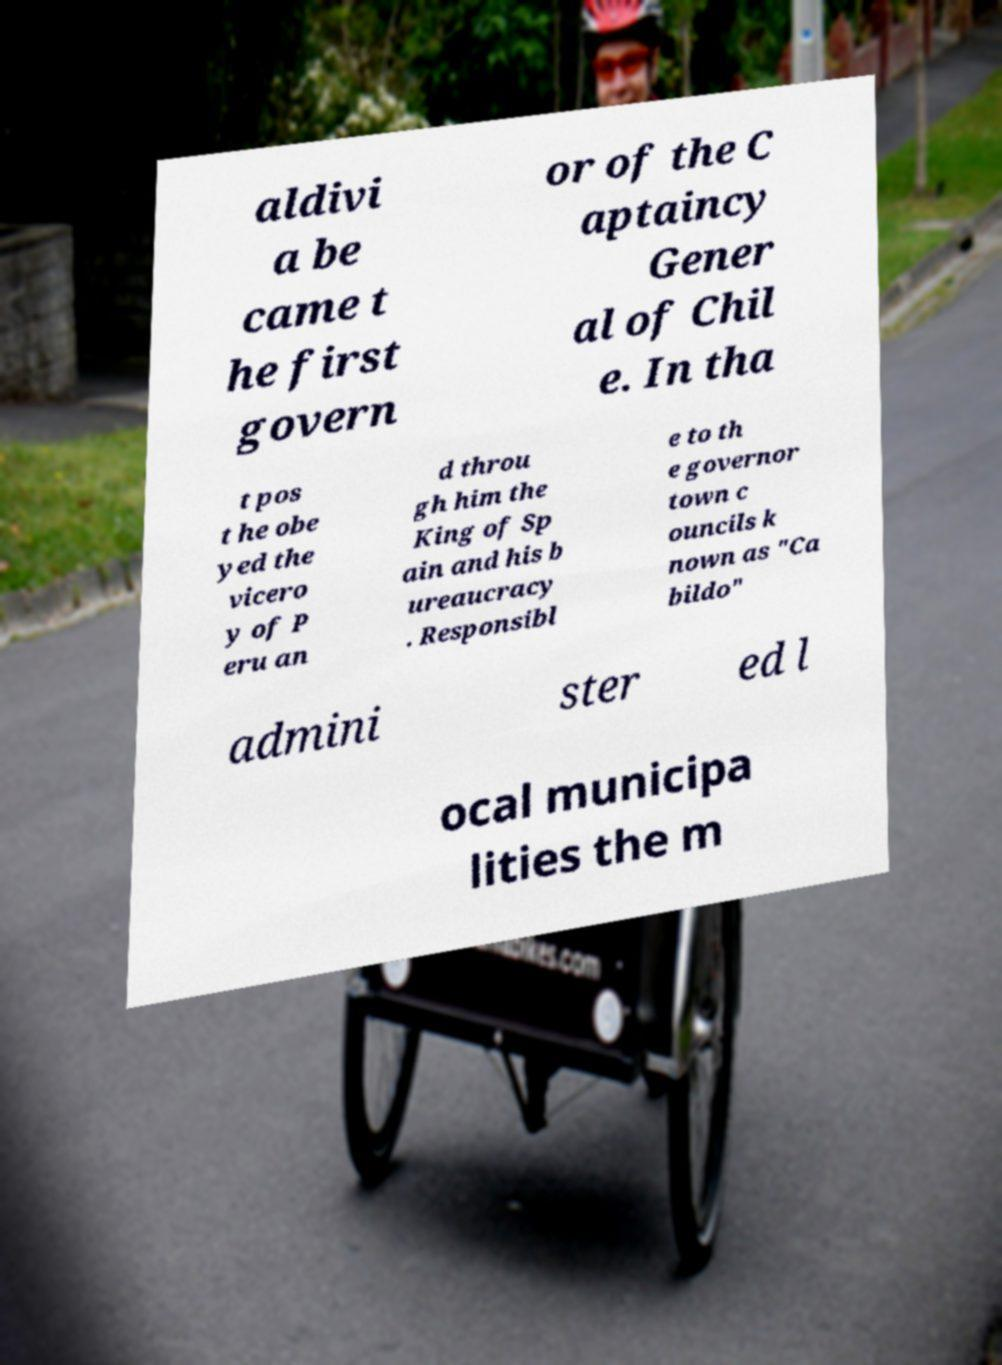Please read and relay the text visible in this image. What does it say? aldivi a be came t he first govern or of the C aptaincy Gener al of Chil e. In tha t pos t he obe yed the vicero y of P eru an d throu gh him the King of Sp ain and his b ureaucracy . Responsibl e to th e governor town c ouncils k nown as "Ca bildo" admini ster ed l ocal municipa lities the m 